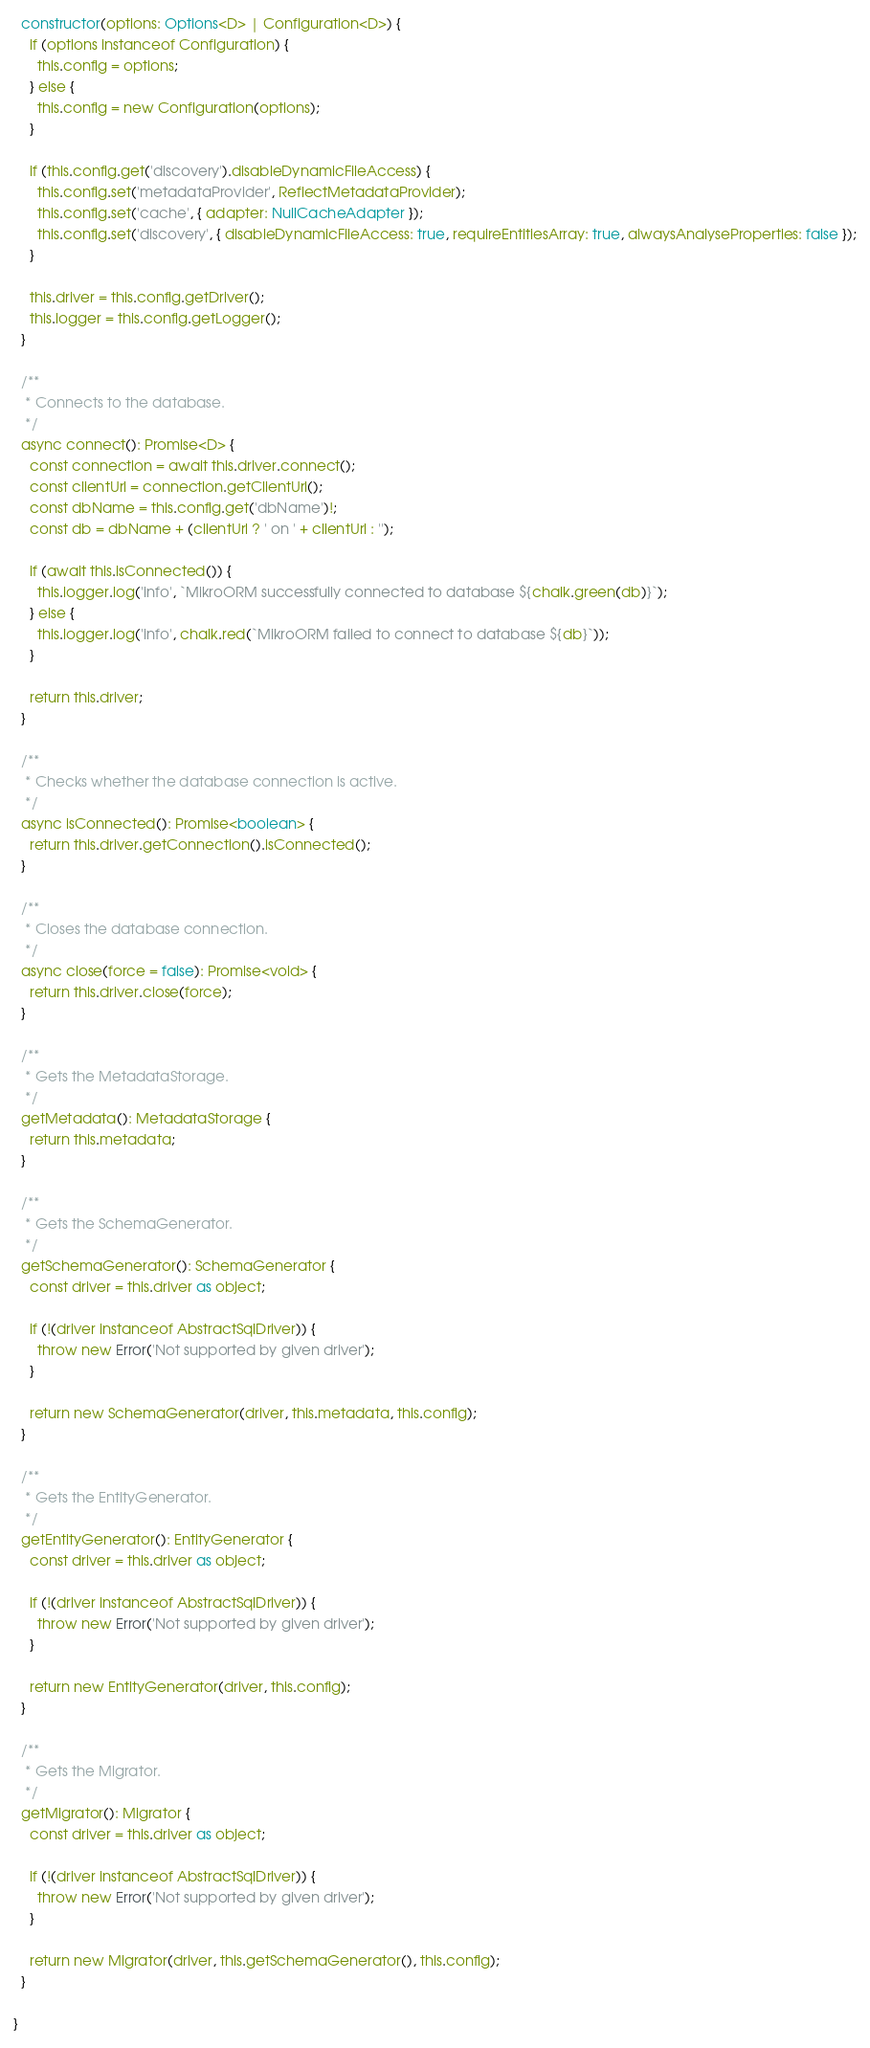Convert code to text. <code><loc_0><loc_0><loc_500><loc_500><_TypeScript_>  constructor(options: Options<D> | Configuration<D>) {
    if (options instanceof Configuration) {
      this.config = options;
    } else {
      this.config = new Configuration(options);
    }

    if (this.config.get('discovery').disableDynamicFileAccess) {
      this.config.set('metadataProvider', ReflectMetadataProvider);
      this.config.set('cache', { adapter: NullCacheAdapter });
      this.config.set('discovery', { disableDynamicFileAccess: true, requireEntitiesArray: true, alwaysAnalyseProperties: false });
    }

    this.driver = this.config.getDriver();
    this.logger = this.config.getLogger();
  }

  /**
   * Connects to the database.
   */
  async connect(): Promise<D> {
    const connection = await this.driver.connect();
    const clientUrl = connection.getClientUrl();
    const dbName = this.config.get('dbName')!;
    const db = dbName + (clientUrl ? ' on ' + clientUrl : '');

    if (await this.isConnected()) {
      this.logger.log('info', `MikroORM successfully connected to database ${chalk.green(db)}`);
    } else {
      this.logger.log('info', chalk.red(`MikroORM failed to connect to database ${db}`));
    }

    return this.driver;
  }

  /**
   * Checks whether the database connection is active.
   */
  async isConnected(): Promise<boolean> {
    return this.driver.getConnection().isConnected();
  }

  /**
   * Closes the database connection.
   */
  async close(force = false): Promise<void> {
    return this.driver.close(force);
  }

  /**
   * Gets the MetadataStorage.
   */
  getMetadata(): MetadataStorage {
    return this.metadata;
  }

  /**
   * Gets the SchemaGenerator.
   */
  getSchemaGenerator(): SchemaGenerator {
    const driver = this.driver as object;

    if (!(driver instanceof AbstractSqlDriver)) {
      throw new Error('Not supported by given driver');
    }

    return new SchemaGenerator(driver, this.metadata, this.config);
  }

  /**
   * Gets the EntityGenerator.
   */
  getEntityGenerator(): EntityGenerator {
    const driver = this.driver as object;

    if (!(driver instanceof AbstractSqlDriver)) {
      throw new Error('Not supported by given driver');
    }

    return new EntityGenerator(driver, this.config);
  }

  /**
   * Gets the Migrator.
   */
  getMigrator(): Migrator {
    const driver = this.driver as object;

    if (!(driver instanceof AbstractSqlDriver)) {
      throw new Error('Not supported by given driver');
    }

    return new Migrator(driver, this.getSchemaGenerator(), this.config);
  }

}
</code> 